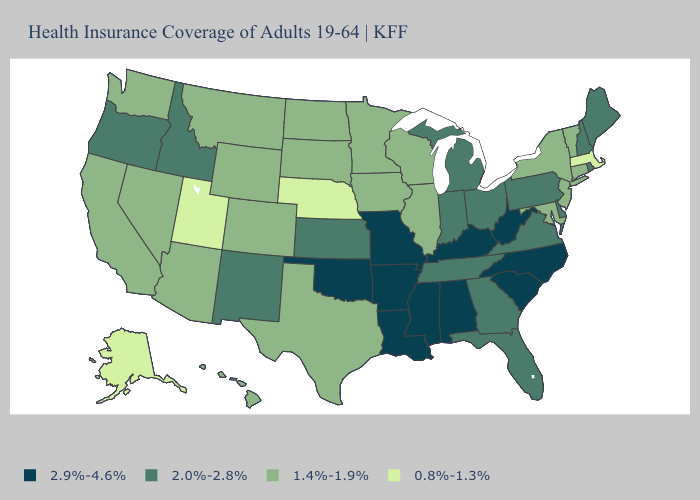Among the states that border Nebraska , which have the highest value?
Answer briefly. Missouri. Does Georgia have the highest value in the South?
Keep it brief. No. What is the highest value in the USA?
Concise answer only. 2.9%-4.6%. Which states have the lowest value in the USA?
Give a very brief answer. Alaska, Massachusetts, Nebraska, Utah. What is the value of Washington?
Give a very brief answer. 1.4%-1.9%. Name the states that have a value in the range 2.9%-4.6%?
Concise answer only. Alabama, Arkansas, Kentucky, Louisiana, Mississippi, Missouri, North Carolina, Oklahoma, South Carolina, West Virginia. Does the map have missing data?
Concise answer only. No. Does Mississippi have a higher value than North Dakota?
Give a very brief answer. Yes. Is the legend a continuous bar?
Give a very brief answer. No. Name the states that have a value in the range 0.8%-1.3%?
Answer briefly. Alaska, Massachusetts, Nebraska, Utah. Name the states that have a value in the range 2.0%-2.8%?
Concise answer only. Delaware, Florida, Georgia, Idaho, Indiana, Kansas, Maine, Michigan, New Hampshire, New Mexico, Ohio, Oregon, Pennsylvania, Rhode Island, Tennessee, Virginia. Does Virginia have the lowest value in the South?
Answer briefly. No. Name the states that have a value in the range 0.8%-1.3%?
Short answer required. Alaska, Massachusetts, Nebraska, Utah. What is the highest value in states that border Oklahoma?
Answer briefly. 2.9%-4.6%. Does Massachusetts have the lowest value in the Northeast?
Be succinct. Yes. 